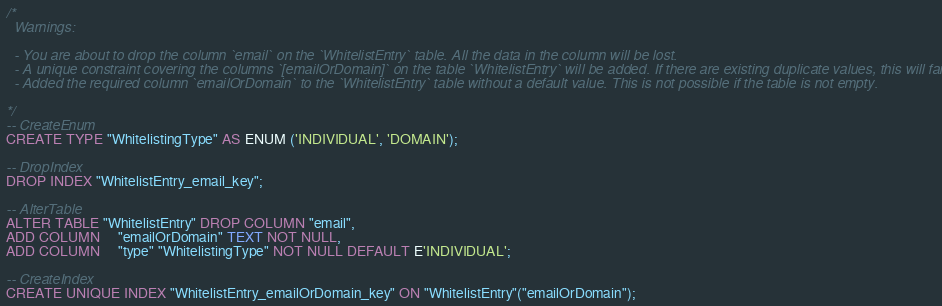Convert code to text. <code><loc_0><loc_0><loc_500><loc_500><_SQL_>/*
  Warnings:

  - You are about to drop the column `email` on the `WhitelistEntry` table. All the data in the column will be lost.
  - A unique constraint covering the columns `[emailOrDomain]` on the table `WhitelistEntry` will be added. If there are existing duplicate values, this will fail.
  - Added the required column `emailOrDomain` to the `WhitelistEntry` table without a default value. This is not possible if the table is not empty.

*/
-- CreateEnum
CREATE TYPE "WhitelistingType" AS ENUM ('INDIVIDUAL', 'DOMAIN');

-- DropIndex
DROP INDEX "WhitelistEntry_email_key";

-- AlterTable
ALTER TABLE "WhitelistEntry" DROP COLUMN "email",
ADD COLUMN     "emailOrDomain" TEXT NOT NULL,
ADD COLUMN     "type" "WhitelistingType" NOT NULL DEFAULT E'INDIVIDUAL';

-- CreateIndex
CREATE UNIQUE INDEX "WhitelistEntry_emailOrDomain_key" ON "WhitelistEntry"("emailOrDomain");
</code> 